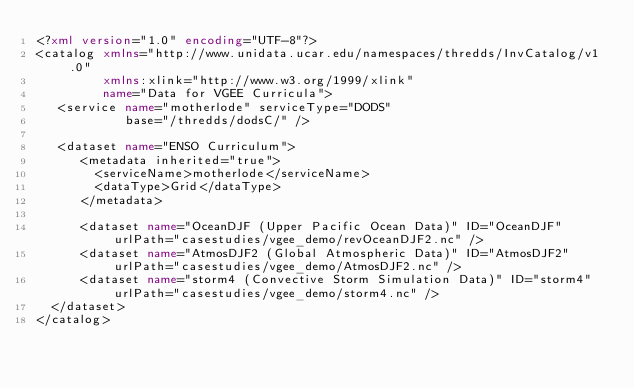Convert code to text. <code><loc_0><loc_0><loc_500><loc_500><_XML_><?xml version="1.0" encoding="UTF-8"?>
<catalog xmlns="http://www.unidata.ucar.edu/namespaces/thredds/InvCatalog/v1.0"
         xmlns:xlink="http://www.w3.org/1999/xlink"
         name="Data for VGEE Curricula">
   <service name="motherlode" serviceType="DODS"
            base="/thredds/dodsC/" />
 
   <dataset name="ENSO Curriculum">
      <metadata inherited="true">
        <serviceName>motherlode</serviceName>
        <dataType>Grid</dataType>
      </metadata>

      <dataset name="OceanDJF (Upper Pacific Ocean Data)" ID="OceanDJF" urlPath="casestudies/vgee_demo/revOceanDJF2.nc" />
      <dataset name="AtmosDJF2 (Global Atmospheric Data)" ID="AtmosDJF2" urlPath="casestudies/vgee_demo/AtmosDJF2.nc" />
      <dataset name="storm4 (Convective Storm Simulation Data)" ID="storm4" urlPath="casestudies/vgee_demo/storm4.nc" />
  </dataset>
</catalog>

</code> 